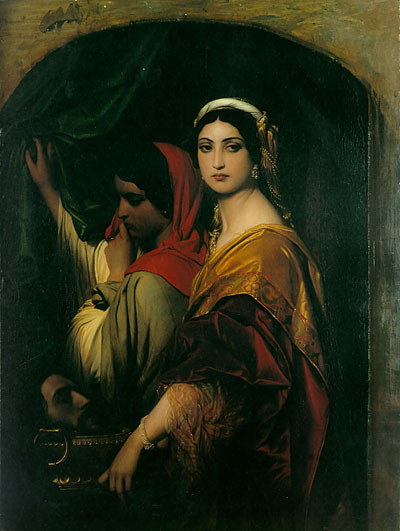What might the expressions on the women's faces tell us about the story being depicted? The woman on the right, with her forthright gaze, exudes a sense of authority and perhaps introspection. Her expression, coupled with her regal attire, might suggest she is a figure of importance, possibly reflecting on a significant decision or occurrence. Conversely, the woman on the left, who is partially hidden, adds an element of mystery and perhaps anticipation, as she gently moves the curtain, perhaps hinting at a narrative of unveiling or discovery. Their expressions invite viewers to ponder over the potential narratives involving secrecy, contemplation, or revelation imbued within this image. 